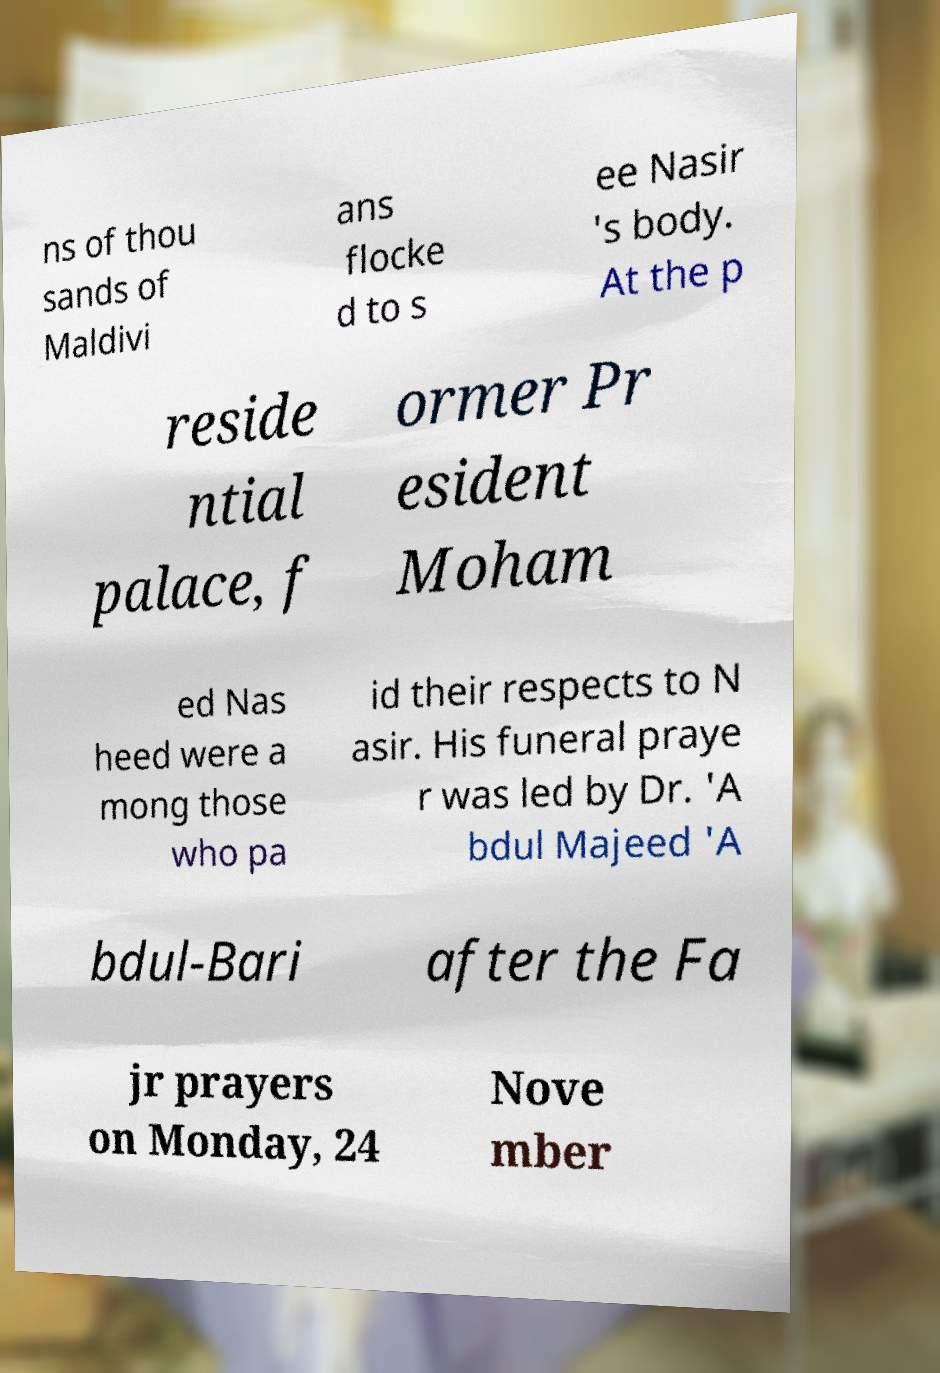I need the written content from this picture converted into text. Can you do that? ns of thou sands of Maldivi ans flocke d to s ee Nasir 's body. At the p reside ntial palace, f ormer Pr esident Moham ed Nas heed were a mong those who pa id their respects to N asir. His funeral praye r was led by Dr. 'A bdul Majeed 'A bdul-Bari after the Fa jr prayers on Monday, 24 Nove mber 